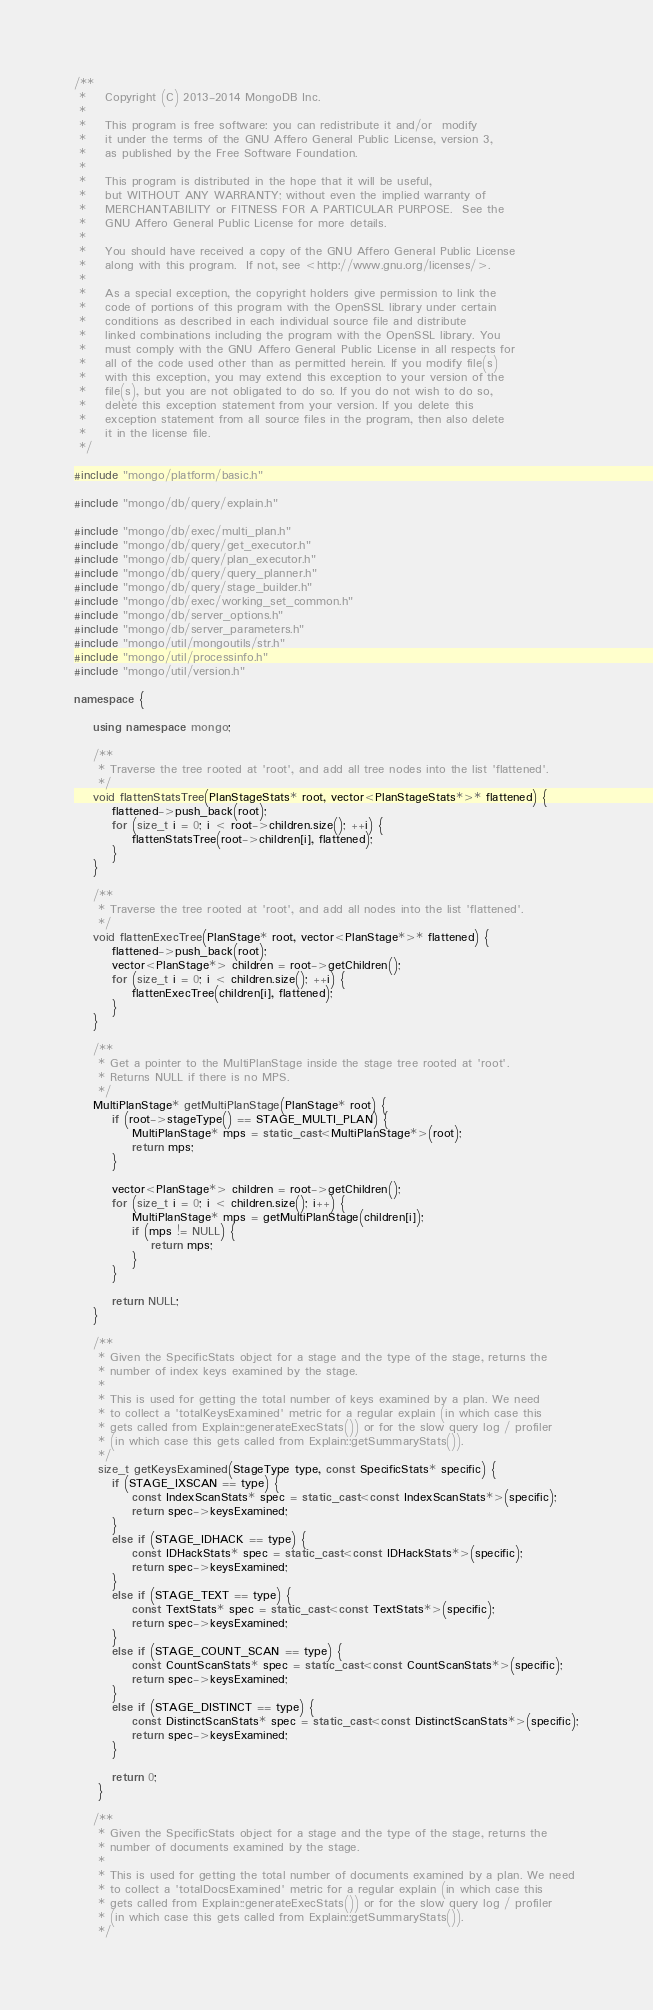<code> <loc_0><loc_0><loc_500><loc_500><_C++_>/**
 *    Copyright (C) 2013-2014 MongoDB Inc.
 *
 *    This program is free software: you can redistribute it and/or  modify
 *    it under the terms of the GNU Affero General Public License, version 3,
 *    as published by the Free Software Foundation.
 *
 *    This program is distributed in the hope that it will be useful,
 *    but WITHOUT ANY WARRANTY; without even the implied warranty of
 *    MERCHANTABILITY or FITNESS FOR A PARTICULAR PURPOSE.  See the
 *    GNU Affero General Public License for more details.
 *
 *    You should have received a copy of the GNU Affero General Public License
 *    along with this program.  If not, see <http://www.gnu.org/licenses/>.
 *
 *    As a special exception, the copyright holders give permission to link the
 *    code of portions of this program with the OpenSSL library under certain
 *    conditions as described in each individual source file and distribute
 *    linked combinations including the program with the OpenSSL library. You
 *    must comply with the GNU Affero General Public License in all respects for
 *    all of the code used other than as permitted herein. If you modify file(s)
 *    with this exception, you may extend this exception to your version of the
 *    file(s), but you are not obligated to do so. If you do not wish to do so,
 *    delete this exception statement from your version. If you delete this
 *    exception statement from all source files in the program, then also delete
 *    it in the license file.
 */

#include "mongo/platform/basic.h"

#include "mongo/db/query/explain.h"

#include "mongo/db/exec/multi_plan.h"
#include "mongo/db/query/get_executor.h"
#include "mongo/db/query/plan_executor.h"
#include "mongo/db/query/query_planner.h"
#include "mongo/db/query/stage_builder.h"
#include "mongo/db/exec/working_set_common.h"
#include "mongo/db/server_options.h"
#include "mongo/db/server_parameters.h"
#include "mongo/util/mongoutils/str.h"
#include "mongo/util/processinfo.h"
#include "mongo/util/version.h"

namespace {

    using namespace mongo;

    /**
     * Traverse the tree rooted at 'root', and add all tree nodes into the list 'flattened'.
     */
    void flattenStatsTree(PlanStageStats* root, vector<PlanStageStats*>* flattened) {
        flattened->push_back(root);
        for (size_t i = 0; i < root->children.size(); ++i) {
            flattenStatsTree(root->children[i], flattened);
        }
    }

    /**
     * Traverse the tree rooted at 'root', and add all nodes into the list 'flattened'.
     */
    void flattenExecTree(PlanStage* root, vector<PlanStage*>* flattened) {
        flattened->push_back(root);
        vector<PlanStage*> children = root->getChildren();
        for (size_t i = 0; i < children.size(); ++i) {
            flattenExecTree(children[i], flattened);
        }
    }

    /**
     * Get a pointer to the MultiPlanStage inside the stage tree rooted at 'root'.
     * Returns NULL if there is no MPS.
     */
    MultiPlanStage* getMultiPlanStage(PlanStage* root) {
        if (root->stageType() == STAGE_MULTI_PLAN) {
            MultiPlanStage* mps = static_cast<MultiPlanStage*>(root);
            return mps;
        }

        vector<PlanStage*> children = root->getChildren();
        for (size_t i = 0; i < children.size(); i++) {
            MultiPlanStage* mps = getMultiPlanStage(children[i]);
            if (mps != NULL) {
                return mps;
            }
        }

        return NULL;
    }

    /**
     * Given the SpecificStats object for a stage and the type of the stage, returns the
     * number of index keys examined by the stage.
     *
     * This is used for getting the total number of keys examined by a plan. We need
     * to collect a 'totalKeysExamined' metric for a regular explain (in which case this
     * gets called from Explain::generateExecStats()) or for the slow query log / profiler
     * (in which case this gets called from Explain::getSummaryStats()).
     */
     size_t getKeysExamined(StageType type, const SpecificStats* specific) {
        if (STAGE_IXSCAN == type) {
            const IndexScanStats* spec = static_cast<const IndexScanStats*>(specific);
            return spec->keysExamined;
        }
        else if (STAGE_IDHACK == type) {
            const IDHackStats* spec = static_cast<const IDHackStats*>(specific);
            return spec->keysExamined;
        }
        else if (STAGE_TEXT == type) {
            const TextStats* spec = static_cast<const TextStats*>(specific);
            return spec->keysExamined;
        }
        else if (STAGE_COUNT_SCAN == type) {
            const CountScanStats* spec = static_cast<const CountScanStats*>(specific);
            return spec->keysExamined;
        }
        else if (STAGE_DISTINCT == type) {
            const DistinctScanStats* spec = static_cast<const DistinctScanStats*>(specific);
            return spec->keysExamined;
        }

        return 0;
     }

    /**
     * Given the SpecificStats object for a stage and the type of the stage, returns the
     * number of documents examined by the stage.
     *
     * This is used for getting the total number of documents examined by a plan. We need
     * to collect a 'totalDocsExamined' metric for a regular explain (in which case this
     * gets called from Explain::generateExecStats()) or for the slow query log / profiler
     * (in which case this gets called from Explain::getSummaryStats()).
     */</code> 